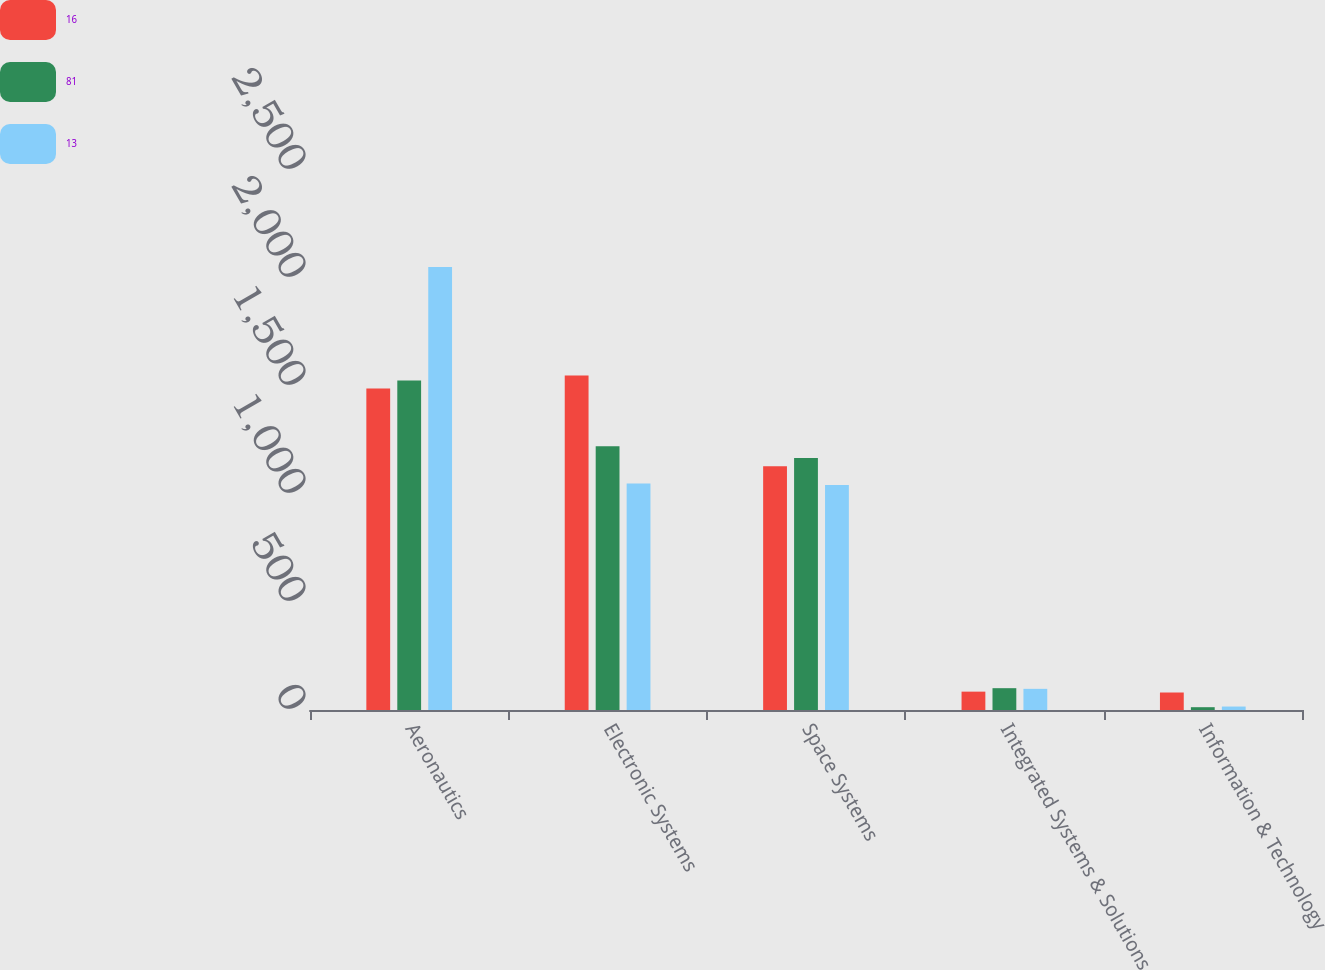Convert chart to OTSL. <chart><loc_0><loc_0><loc_500><loc_500><stacked_bar_chart><ecel><fcel>Aeronautics<fcel>Electronic Systems<fcel>Space Systems<fcel>Integrated Systems & Solutions<fcel>Information & Technology<nl><fcel>16<fcel>1488<fcel>1549<fcel>1128<fcel>85<fcel>81<nl><fcel>81<fcel>1526<fcel>1221<fcel>1167<fcel>101<fcel>13<nl><fcel>13<fcel>2051<fcel>1049<fcel>1042<fcel>98<fcel>16<nl></chart> 